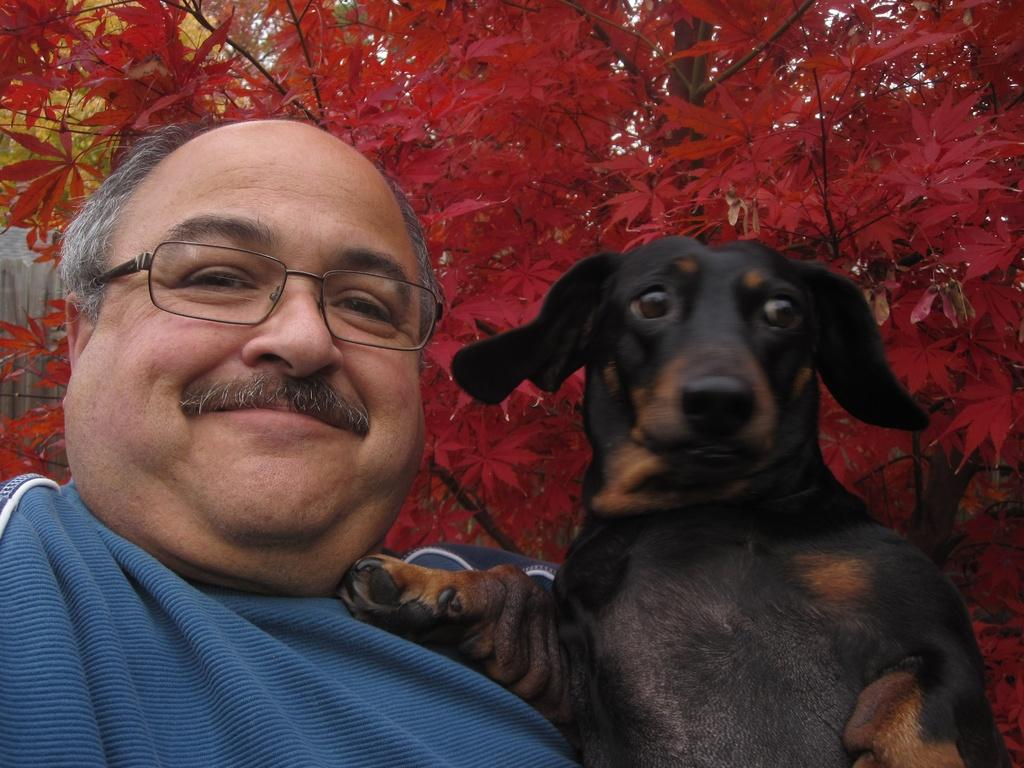Who is present in the image? There is a man in the image. What is the man doing in the image? The man is smiling. What other living creature is present in the image? There is a black dog in the image. How is the black dog depicted in the image? The black dog is smiling. What can be seen in the background of the image? There are beautiful red flowers in the background of the image. Where is the toad sitting on the branch in the image? There is no toad or branch present in the image. How does the man wash the dog in the image? There is no indication in the image that the man is washing the dog, as both the man and the dog are depicted as smiling. 